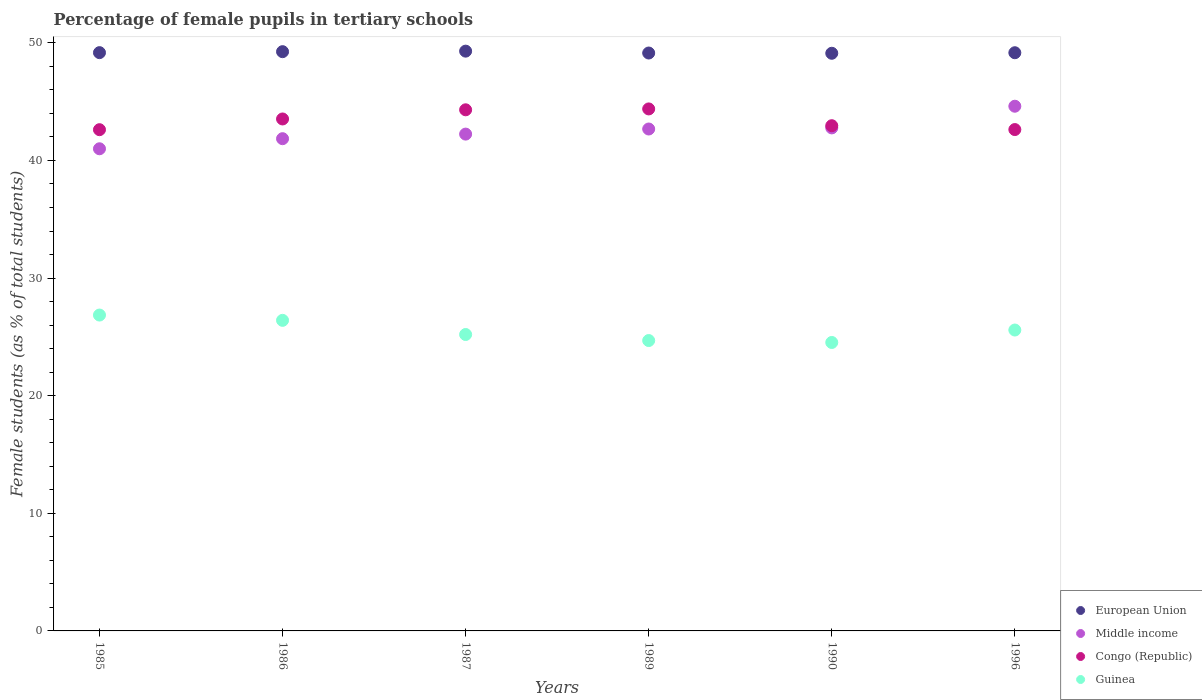What is the percentage of female pupils in tertiary schools in Guinea in 1986?
Provide a succinct answer. 26.41. Across all years, what is the maximum percentage of female pupils in tertiary schools in Middle income?
Your answer should be very brief. 44.61. Across all years, what is the minimum percentage of female pupils in tertiary schools in Guinea?
Give a very brief answer. 24.52. What is the total percentage of female pupils in tertiary schools in European Union in the graph?
Give a very brief answer. 295.12. What is the difference between the percentage of female pupils in tertiary schools in Congo (Republic) in 1985 and that in 1990?
Your answer should be compact. -0.34. What is the difference between the percentage of female pupils in tertiary schools in European Union in 1990 and the percentage of female pupils in tertiary schools in Middle income in 1996?
Offer a very short reply. 4.5. What is the average percentage of female pupils in tertiary schools in Guinea per year?
Ensure brevity in your answer.  25.54. In the year 1996, what is the difference between the percentage of female pupils in tertiary schools in Guinea and percentage of female pupils in tertiary schools in Middle income?
Keep it short and to the point. -19.03. What is the ratio of the percentage of female pupils in tertiary schools in European Union in 1985 to that in 1990?
Provide a succinct answer. 1. What is the difference between the highest and the second highest percentage of female pupils in tertiary schools in Guinea?
Your answer should be compact. 0.45. What is the difference between the highest and the lowest percentage of female pupils in tertiary schools in Congo (Republic)?
Provide a short and direct response. 1.76. In how many years, is the percentage of female pupils in tertiary schools in Congo (Republic) greater than the average percentage of female pupils in tertiary schools in Congo (Republic) taken over all years?
Keep it short and to the point. 3. Is it the case that in every year, the sum of the percentage of female pupils in tertiary schools in Congo (Republic) and percentage of female pupils in tertiary schools in Guinea  is greater than the percentage of female pupils in tertiary schools in European Union?
Your answer should be compact. Yes. Does the percentage of female pupils in tertiary schools in Congo (Republic) monotonically increase over the years?
Your answer should be compact. No. Is the percentage of female pupils in tertiary schools in Middle income strictly less than the percentage of female pupils in tertiary schools in Congo (Republic) over the years?
Your response must be concise. No. How many years are there in the graph?
Ensure brevity in your answer.  6. What is the difference between two consecutive major ticks on the Y-axis?
Your response must be concise. 10. Where does the legend appear in the graph?
Offer a terse response. Bottom right. How many legend labels are there?
Give a very brief answer. 4. How are the legend labels stacked?
Keep it short and to the point. Vertical. What is the title of the graph?
Make the answer very short. Percentage of female pupils in tertiary schools. What is the label or title of the X-axis?
Provide a short and direct response. Years. What is the label or title of the Y-axis?
Give a very brief answer. Female students (as % of total students). What is the Female students (as % of total students) in European Union in 1985?
Your response must be concise. 49.17. What is the Female students (as % of total students) in Middle income in 1985?
Ensure brevity in your answer.  40.99. What is the Female students (as % of total students) in Congo (Republic) in 1985?
Keep it short and to the point. 42.62. What is the Female students (as % of total students) of Guinea in 1985?
Keep it short and to the point. 26.86. What is the Female students (as % of total students) in European Union in 1986?
Offer a terse response. 49.25. What is the Female students (as % of total students) of Middle income in 1986?
Make the answer very short. 41.85. What is the Female students (as % of total students) in Congo (Republic) in 1986?
Keep it short and to the point. 43.53. What is the Female students (as % of total students) of Guinea in 1986?
Your answer should be compact. 26.41. What is the Female students (as % of total students) of European Union in 1987?
Give a very brief answer. 49.3. What is the Female students (as % of total students) in Middle income in 1987?
Offer a very short reply. 42.24. What is the Female students (as % of total students) in Congo (Republic) in 1987?
Your answer should be compact. 44.31. What is the Female students (as % of total students) of Guinea in 1987?
Keep it short and to the point. 25.2. What is the Female students (as % of total students) of European Union in 1989?
Ensure brevity in your answer.  49.14. What is the Female students (as % of total students) in Middle income in 1989?
Make the answer very short. 42.67. What is the Female students (as % of total students) in Congo (Republic) in 1989?
Your response must be concise. 44.38. What is the Female students (as % of total students) of Guinea in 1989?
Offer a very short reply. 24.69. What is the Female students (as % of total students) in European Union in 1990?
Keep it short and to the point. 49.11. What is the Female students (as % of total students) in Middle income in 1990?
Offer a very short reply. 42.77. What is the Female students (as % of total students) in Congo (Republic) in 1990?
Provide a succinct answer. 42.95. What is the Female students (as % of total students) in Guinea in 1990?
Ensure brevity in your answer.  24.52. What is the Female students (as % of total students) of European Union in 1996?
Your response must be concise. 49.16. What is the Female students (as % of total students) of Middle income in 1996?
Keep it short and to the point. 44.61. What is the Female students (as % of total students) of Congo (Republic) in 1996?
Your response must be concise. 42.63. What is the Female students (as % of total students) of Guinea in 1996?
Keep it short and to the point. 25.58. Across all years, what is the maximum Female students (as % of total students) of European Union?
Keep it short and to the point. 49.3. Across all years, what is the maximum Female students (as % of total students) of Middle income?
Your response must be concise. 44.61. Across all years, what is the maximum Female students (as % of total students) of Congo (Republic)?
Provide a succinct answer. 44.38. Across all years, what is the maximum Female students (as % of total students) in Guinea?
Keep it short and to the point. 26.86. Across all years, what is the minimum Female students (as % of total students) of European Union?
Make the answer very short. 49.11. Across all years, what is the minimum Female students (as % of total students) of Middle income?
Offer a terse response. 40.99. Across all years, what is the minimum Female students (as % of total students) in Congo (Republic)?
Keep it short and to the point. 42.62. Across all years, what is the minimum Female students (as % of total students) of Guinea?
Provide a succinct answer. 24.52. What is the total Female students (as % of total students) of European Union in the graph?
Your answer should be very brief. 295.12. What is the total Female students (as % of total students) in Middle income in the graph?
Your answer should be very brief. 255.14. What is the total Female students (as % of total students) of Congo (Republic) in the graph?
Make the answer very short. 260.42. What is the total Female students (as % of total students) of Guinea in the graph?
Your response must be concise. 153.26. What is the difference between the Female students (as % of total students) in European Union in 1985 and that in 1986?
Give a very brief answer. -0.08. What is the difference between the Female students (as % of total students) of Middle income in 1985 and that in 1986?
Give a very brief answer. -0.86. What is the difference between the Female students (as % of total students) in Congo (Republic) in 1985 and that in 1986?
Your answer should be very brief. -0.91. What is the difference between the Female students (as % of total students) in Guinea in 1985 and that in 1986?
Provide a succinct answer. 0.45. What is the difference between the Female students (as % of total students) of European Union in 1985 and that in 1987?
Your answer should be very brief. -0.13. What is the difference between the Female students (as % of total students) in Middle income in 1985 and that in 1987?
Give a very brief answer. -1.25. What is the difference between the Female students (as % of total students) in Congo (Republic) in 1985 and that in 1987?
Provide a short and direct response. -1.69. What is the difference between the Female students (as % of total students) in Guinea in 1985 and that in 1987?
Your answer should be very brief. 1.65. What is the difference between the Female students (as % of total students) of European Union in 1985 and that in 1989?
Your response must be concise. 0.03. What is the difference between the Female students (as % of total students) of Middle income in 1985 and that in 1989?
Give a very brief answer. -1.68. What is the difference between the Female students (as % of total students) in Congo (Republic) in 1985 and that in 1989?
Give a very brief answer. -1.76. What is the difference between the Female students (as % of total students) in Guinea in 1985 and that in 1989?
Offer a terse response. 2.17. What is the difference between the Female students (as % of total students) of European Union in 1985 and that in 1990?
Your response must be concise. 0.05. What is the difference between the Female students (as % of total students) of Middle income in 1985 and that in 1990?
Your response must be concise. -1.77. What is the difference between the Female students (as % of total students) in Congo (Republic) in 1985 and that in 1990?
Your answer should be compact. -0.34. What is the difference between the Female students (as % of total students) in Guinea in 1985 and that in 1990?
Give a very brief answer. 2.33. What is the difference between the Female students (as % of total students) of European Union in 1985 and that in 1996?
Provide a short and direct response. 0.01. What is the difference between the Female students (as % of total students) of Middle income in 1985 and that in 1996?
Your answer should be very brief. -3.62. What is the difference between the Female students (as % of total students) of Congo (Republic) in 1985 and that in 1996?
Keep it short and to the point. -0.01. What is the difference between the Female students (as % of total students) in Guinea in 1985 and that in 1996?
Your response must be concise. 1.27. What is the difference between the Female students (as % of total students) in European Union in 1986 and that in 1987?
Ensure brevity in your answer.  -0.04. What is the difference between the Female students (as % of total students) of Middle income in 1986 and that in 1987?
Keep it short and to the point. -0.39. What is the difference between the Female students (as % of total students) in Congo (Republic) in 1986 and that in 1987?
Provide a short and direct response. -0.78. What is the difference between the Female students (as % of total students) of Guinea in 1986 and that in 1987?
Keep it short and to the point. 1.2. What is the difference between the Female students (as % of total students) in European Union in 1986 and that in 1989?
Keep it short and to the point. 0.11. What is the difference between the Female students (as % of total students) of Middle income in 1986 and that in 1989?
Ensure brevity in your answer.  -0.82. What is the difference between the Female students (as % of total students) in Congo (Republic) in 1986 and that in 1989?
Your answer should be compact. -0.85. What is the difference between the Female students (as % of total students) in Guinea in 1986 and that in 1989?
Your response must be concise. 1.72. What is the difference between the Female students (as % of total students) of European Union in 1986 and that in 1990?
Ensure brevity in your answer.  0.14. What is the difference between the Female students (as % of total students) in Middle income in 1986 and that in 1990?
Ensure brevity in your answer.  -0.92. What is the difference between the Female students (as % of total students) in Congo (Republic) in 1986 and that in 1990?
Make the answer very short. 0.57. What is the difference between the Female students (as % of total students) in Guinea in 1986 and that in 1990?
Your answer should be compact. 1.88. What is the difference between the Female students (as % of total students) of European Union in 1986 and that in 1996?
Provide a succinct answer. 0.09. What is the difference between the Female students (as % of total students) in Middle income in 1986 and that in 1996?
Provide a short and direct response. -2.76. What is the difference between the Female students (as % of total students) of Congo (Republic) in 1986 and that in 1996?
Ensure brevity in your answer.  0.9. What is the difference between the Female students (as % of total students) in Guinea in 1986 and that in 1996?
Provide a succinct answer. 0.82. What is the difference between the Female students (as % of total students) in European Union in 1987 and that in 1989?
Give a very brief answer. 0.16. What is the difference between the Female students (as % of total students) of Middle income in 1987 and that in 1989?
Provide a succinct answer. -0.43. What is the difference between the Female students (as % of total students) in Congo (Republic) in 1987 and that in 1989?
Your answer should be compact. -0.07. What is the difference between the Female students (as % of total students) of Guinea in 1987 and that in 1989?
Give a very brief answer. 0.51. What is the difference between the Female students (as % of total students) in European Union in 1987 and that in 1990?
Provide a short and direct response. 0.18. What is the difference between the Female students (as % of total students) in Middle income in 1987 and that in 1990?
Provide a short and direct response. -0.53. What is the difference between the Female students (as % of total students) of Congo (Republic) in 1987 and that in 1990?
Your answer should be compact. 1.35. What is the difference between the Female students (as % of total students) in Guinea in 1987 and that in 1990?
Give a very brief answer. 0.68. What is the difference between the Female students (as % of total students) of European Union in 1987 and that in 1996?
Your answer should be very brief. 0.14. What is the difference between the Female students (as % of total students) of Middle income in 1987 and that in 1996?
Your response must be concise. -2.37. What is the difference between the Female students (as % of total students) of Congo (Republic) in 1987 and that in 1996?
Your answer should be very brief. 1.68. What is the difference between the Female students (as % of total students) in Guinea in 1987 and that in 1996?
Your answer should be compact. -0.38. What is the difference between the Female students (as % of total students) of European Union in 1989 and that in 1990?
Your answer should be very brief. 0.02. What is the difference between the Female students (as % of total students) of Middle income in 1989 and that in 1990?
Offer a very short reply. -0.09. What is the difference between the Female students (as % of total students) of Congo (Republic) in 1989 and that in 1990?
Offer a very short reply. 1.43. What is the difference between the Female students (as % of total students) in Guinea in 1989 and that in 1990?
Provide a short and direct response. 0.16. What is the difference between the Female students (as % of total students) of European Union in 1989 and that in 1996?
Your response must be concise. -0.02. What is the difference between the Female students (as % of total students) in Middle income in 1989 and that in 1996?
Ensure brevity in your answer.  -1.94. What is the difference between the Female students (as % of total students) of Congo (Republic) in 1989 and that in 1996?
Offer a very short reply. 1.75. What is the difference between the Female students (as % of total students) in Guinea in 1989 and that in 1996?
Offer a terse response. -0.89. What is the difference between the Female students (as % of total students) of European Union in 1990 and that in 1996?
Keep it short and to the point. -0.05. What is the difference between the Female students (as % of total students) in Middle income in 1990 and that in 1996?
Provide a succinct answer. -1.84. What is the difference between the Female students (as % of total students) in Congo (Republic) in 1990 and that in 1996?
Your answer should be compact. 0.33. What is the difference between the Female students (as % of total students) in Guinea in 1990 and that in 1996?
Make the answer very short. -1.06. What is the difference between the Female students (as % of total students) of European Union in 1985 and the Female students (as % of total students) of Middle income in 1986?
Keep it short and to the point. 7.32. What is the difference between the Female students (as % of total students) in European Union in 1985 and the Female students (as % of total students) in Congo (Republic) in 1986?
Your answer should be very brief. 5.64. What is the difference between the Female students (as % of total students) of European Union in 1985 and the Female students (as % of total students) of Guinea in 1986?
Provide a succinct answer. 22.76. What is the difference between the Female students (as % of total students) of Middle income in 1985 and the Female students (as % of total students) of Congo (Republic) in 1986?
Your response must be concise. -2.53. What is the difference between the Female students (as % of total students) of Middle income in 1985 and the Female students (as % of total students) of Guinea in 1986?
Your answer should be compact. 14.59. What is the difference between the Female students (as % of total students) in Congo (Republic) in 1985 and the Female students (as % of total students) in Guinea in 1986?
Ensure brevity in your answer.  16.21. What is the difference between the Female students (as % of total students) of European Union in 1985 and the Female students (as % of total students) of Middle income in 1987?
Offer a very short reply. 6.93. What is the difference between the Female students (as % of total students) of European Union in 1985 and the Female students (as % of total students) of Congo (Republic) in 1987?
Provide a short and direct response. 4.86. What is the difference between the Female students (as % of total students) of European Union in 1985 and the Female students (as % of total students) of Guinea in 1987?
Your answer should be very brief. 23.97. What is the difference between the Female students (as % of total students) of Middle income in 1985 and the Female students (as % of total students) of Congo (Republic) in 1987?
Provide a succinct answer. -3.31. What is the difference between the Female students (as % of total students) in Middle income in 1985 and the Female students (as % of total students) in Guinea in 1987?
Provide a succinct answer. 15.79. What is the difference between the Female students (as % of total students) of Congo (Republic) in 1985 and the Female students (as % of total students) of Guinea in 1987?
Offer a terse response. 17.41. What is the difference between the Female students (as % of total students) in European Union in 1985 and the Female students (as % of total students) in Middle income in 1989?
Your answer should be very brief. 6.49. What is the difference between the Female students (as % of total students) of European Union in 1985 and the Female students (as % of total students) of Congo (Republic) in 1989?
Ensure brevity in your answer.  4.79. What is the difference between the Female students (as % of total students) of European Union in 1985 and the Female students (as % of total students) of Guinea in 1989?
Your answer should be very brief. 24.48. What is the difference between the Female students (as % of total students) in Middle income in 1985 and the Female students (as % of total students) in Congo (Republic) in 1989?
Offer a terse response. -3.39. What is the difference between the Female students (as % of total students) of Middle income in 1985 and the Female students (as % of total students) of Guinea in 1989?
Provide a short and direct response. 16.31. What is the difference between the Female students (as % of total students) in Congo (Republic) in 1985 and the Female students (as % of total students) in Guinea in 1989?
Provide a short and direct response. 17.93. What is the difference between the Female students (as % of total students) of European Union in 1985 and the Female students (as % of total students) of Middle income in 1990?
Keep it short and to the point. 6.4. What is the difference between the Female students (as % of total students) in European Union in 1985 and the Female students (as % of total students) in Congo (Republic) in 1990?
Give a very brief answer. 6.21. What is the difference between the Female students (as % of total students) of European Union in 1985 and the Female students (as % of total students) of Guinea in 1990?
Offer a terse response. 24.64. What is the difference between the Female students (as % of total students) of Middle income in 1985 and the Female students (as % of total students) of Congo (Republic) in 1990?
Ensure brevity in your answer.  -1.96. What is the difference between the Female students (as % of total students) of Middle income in 1985 and the Female students (as % of total students) of Guinea in 1990?
Offer a very short reply. 16.47. What is the difference between the Female students (as % of total students) in Congo (Republic) in 1985 and the Female students (as % of total students) in Guinea in 1990?
Keep it short and to the point. 18.09. What is the difference between the Female students (as % of total students) in European Union in 1985 and the Female students (as % of total students) in Middle income in 1996?
Give a very brief answer. 4.56. What is the difference between the Female students (as % of total students) of European Union in 1985 and the Female students (as % of total students) of Congo (Republic) in 1996?
Offer a terse response. 6.54. What is the difference between the Female students (as % of total students) in European Union in 1985 and the Female students (as % of total students) in Guinea in 1996?
Your answer should be compact. 23.58. What is the difference between the Female students (as % of total students) of Middle income in 1985 and the Female students (as % of total students) of Congo (Republic) in 1996?
Offer a very short reply. -1.63. What is the difference between the Female students (as % of total students) in Middle income in 1985 and the Female students (as % of total students) in Guinea in 1996?
Ensure brevity in your answer.  15.41. What is the difference between the Female students (as % of total students) in Congo (Republic) in 1985 and the Female students (as % of total students) in Guinea in 1996?
Make the answer very short. 17.03. What is the difference between the Female students (as % of total students) of European Union in 1986 and the Female students (as % of total students) of Middle income in 1987?
Provide a short and direct response. 7.01. What is the difference between the Female students (as % of total students) of European Union in 1986 and the Female students (as % of total students) of Congo (Republic) in 1987?
Provide a succinct answer. 4.94. What is the difference between the Female students (as % of total students) in European Union in 1986 and the Female students (as % of total students) in Guinea in 1987?
Your answer should be compact. 24.05. What is the difference between the Female students (as % of total students) of Middle income in 1986 and the Female students (as % of total students) of Congo (Republic) in 1987?
Keep it short and to the point. -2.46. What is the difference between the Female students (as % of total students) in Middle income in 1986 and the Female students (as % of total students) in Guinea in 1987?
Give a very brief answer. 16.65. What is the difference between the Female students (as % of total students) in Congo (Republic) in 1986 and the Female students (as % of total students) in Guinea in 1987?
Give a very brief answer. 18.33. What is the difference between the Female students (as % of total students) in European Union in 1986 and the Female students (as % of total students) in Middle income in 1989?
Ensure brevity in your answer.  6.58. What is the difference between the Female students (as % of total students) in European Union in 1986 and the Female students (as % of total students) in Congo (Republic) in 1989?
Give a very brief answer. 4.87. What is the difference between the Female students (as % of total students) of European Union in 1986 and the Female students (as % of total students) of Guinea in 1989?
Provide a succinct answer. 24.56. What is the difference between the Female students (as % of total students) in Middle income in 1986 and the Female students (as % of total students) in Congo (Republic) in 1989?
Your response must be concise. -2.53. What is the difference between the Female students (as % of total students) of Middle income in 1986 and the Female students (as % of total students) of Guinea in 1989?
Give a very brief answer. 17.16. What is the difference between the Female students (as % of total students) in Congo (Republic) in 1986 and the Female students (as % of total students) in Guinea in 1989?
Ensure brevity in your answer.  18.84. What is the difference between the Female students (as % of total students) of European Union in 1986 and the Female students (as % of total students) of Middle income in 1990?
Offer a terse response. 6.48. What is the difference between the Female students (as % of total students) of European Union in 1986 and the Female students (as % of total students) of Congo (Republic) in 1990?
Offer a very short reply. 6.3. What is the difference between the Female students (as % of total students) in European Union in 1986 and the Female students (as % of total students) in Guinea in 1990?
Keep it short and to the point. 24.73. What is the difference between the Female students (as % of total students) of Middle income in 1986 and the Female students (as % of total students) of Congo (Republic) in 1990?
Offer a very short reply. -1.1. What is the difference between the Female students (as % of total students) in Middle income in 1986 and the Female students (as % of total students) in Guinea in 1990?
Offer a very short reply. 17.33. What is the difference between the Female students (as % of total students) in Congo (Republic) in 1986 and the Female students (as % of total students) in Guinea in 1990?
Give a very brief answer. 19. What is the difference between the Female students (as % of total students) in European Union in 1986 and the Female students (as % of total students) in Middle income in 1996?
Your response must be concise. 4.64. What is the difference between the Female students (as % of total students) of European Union in 1986 and the Female students (as % of total students) of Congo (Republic) in 1996?
Provide a short and direct response. 6.62. What is the difference between the Female students (as % of total students) in European Union in 1986 and the Female students (as % of total students) in Guinea in 1996?
Your answer should be compact. 23.67. What is the difference between the Female students (as % of total students) in Middle income in 1986 and the Female students (as % of total students) in Congo (Republic) in 1996?
Ensure brevity in your answer.  -0.78. What is the difference between the Female students (as % of total students) of Middle income in 1986 and the Female students (as % of total students) of Guinea in 1996?
Your answer should be compact. 16.27. What is the difference between the Female students (as % of total students) of Congo (Republic) in 1986 and the Female students (as % of total students) of Guinea in 1996?
Provide a succinct answer. 17.95. What is the difference between the Female students (as % of total students) in European Union in 1987 and the Female students (as % of total students) in Middle income in 1989?
Give a very brief answer. 6.62. What is the difference between the Female students (as % of total students) of European Union in 1987 and the Female students (as % of total students) of Congo (Republic) in 1989?
Keep it short and to the point. 4.91. What is the difference between the Female students (as % of total students) in European Union in 1987 and the Female students (as % of total students) in Guinea in 1989?
Offer a terse response. 24.61. What is the difference between the Female students (as % of total students) of Middle income in 1987 and the Female students (as % of total students) of Congo (Republic) in 1989?
Your answer should be compact. -2.14. What is the difference between the Female students (as % of total students) in Middle income in 1987 and the Female students (as % of total students) in Guinea in 1989?
Your response must be concise. 17.55. What is the difference between the Female students (as % of total students) of Congo (Republic) in 1987 and the Female students (as % of total students) of Guinea in 1989?
Keep it short and to the point. 19.62. What is the difference between the Female students (as % of total students) of European Union in 1987 and the Female students (as % of total students) of Middle income in 1990?
Your answer should be compact. 6.53. What is the difference between the Female students (as % of total students) in European Union in 1987 and the Female students (as % of total students) in Congo (Republic) in 1990?
Your answer should be very brief. 6.34. What is the difference between the Female students (as % of total students) of European Union in 1987 and the Female students (as % of total students) of Guinea in 1990?
Give a very brief answer. 24.77. What is the difference between the Female students (as % of total students) of Middle income in 1987 and the Female students (as % of total students) of Congo (Republic) in 1990?
Make the answer very short. -0.71. What is the difference between the Female students (as % of total students) of Middle income in 1987 and the Female students (as % of total students) of Guinea in 1990?
Provide a short and direct response. 17.72. What is the difference between the Female students (as % of total students) of Congo (Republic) in 1987 and the Female students (as % of total students) of Guinea in 1990?
Keep it short and to the point. 19.78. What is the difference between the Female students (as % of total students) of European Union in 1987 and the Female students (as % of total students) of Middle income in 1996?
Your answer should be compact. 4.68. What is the difference between the Female students (as % of total students) of European Union in 1987 and the Female students (as % of total students) of Congo (Republic) in 1996?
Offer a terse response. 6.67. What is the difference between the Female students (as % of total students) of European Union in 1987 and the Female students (as % of total students) of Guinea in 1996?
Ensure brevity in your answer.  23.71. What is the difference between the Female students (as % of total students) in Middle income in 1987 and the Female students (as % of total students) in Congo (Republic) in 1996?
Ensure brevity in your answer.  -0.39. What is the difference between the Female students (as % of total students) of Middle income in 1987 and the Female students (as % of total students) of Guinea in 1996?
Offer a very short reply. 16.66. What is the difference between the Female students (as % of total students) of Congo (Republic) in 1987 and the Female students (as % of total students) of Guinea in 1996?
Provide a short and direct response. 18.72. What is the difference between the Female students (as % of total students) in European Union in 1989 and the Female students (as % of total students) in Middle income in 1990?
Provide a succinct answer. 6.37. What is the difference between the Female students (as % of total students) in European Union in 1989 and the Female students (as % of total students) in Congo (Republic) in 1990?
Provide a short and direct response. 6.18. What is the difference between the Female students (as % of total students) in European Union in 1989 and the Female students (as % of total students) in Guinea in 1990?
Keep it short and to the point. 24.61. What is the difference between the Female students (as % of total students) of Middle income in 1989 and the Female students (as % of total students) of Congo (Republic) in 1990?
Provide a short and direct response. -0.28. What is the difference between the Female students (as % of total students) of Middle income in 1989 and the Female students (as % of total students) of Guinea in 1990?
Provide a short and direct response. 18.15. What is the difference between the Female students (as % of total students) of Congo (Republic) in 1989 and the Female students (as % of total students) of Guinea in 1990?
Keep it short and to the point. 19.86. What is the difference between the Female students (as % of total students) in European Union in 1989 and the Female students (as % of total students) in Middle income in 1996?
Provide a succinct answer. 4.52. What is the difference between the Female students (as % of total students) of European Union in 1989 and the Female students (as % of total students) of Congo (Republic) in 1996?
Offer a very short reply. 6.51. What is the difference between the Female students (as % of total students) in European Union in 1989 and the Female students (as % of total students) in Guinea in 1996?
Your answer should be very brief. 23.55. What is the difference between the Female students (as % of total students) of Middle income in 1989 and the Female students (as % of total students) of Congo (Republic) in 1996?
Ensure brevity in your answer.  0.05. What is the difference between the Female students (as % of total students) in Middle income in 1989 and the Female students (as % of total students) in Guinea in 1996?
Your answer should be very brief. 17.09. What is the difference between the Female students (as % of total students) in Congo (Republic) in 1989 and the Female students (as % of total students) in Guinea in 1996?
Offer a very short reply. 18.8. What is the difference between the Female students (as % of total students) of European Union in 1990 and the Female students (as % of total students) of Middle income in 1996?
Give a very brief answer. 4.5. What is the difference between the Female students (as % of total students) of European Union in 1990 and the Female students (as % of total students) of Congo (Republic) in 1996?
Offer a very short reply. 6.49. What is the difference between the Female students (as % of total students) of European Union in 1990 and the Female students (as % of total students) of Guinea in 1996?
Ensure brevity in your answer.  23.53. What is the difference between the Female students (as % of total students) in Middle income in 1990 and the Female students (as % of total students) in Congo (Republic) in 1996?
Keep it short and to the point. 0.14. What is the difference between the Female students (as % of total students) of Middle income in 1990 and the Female students (as % of total students) of Guinea in 1996?
Give a very brief answer. 17.19. What is the difference between the Female students (as % of total students) of Congo (Republic) in 1990 and the Female students (as % of total students) of Guinea in 1996?
Give a very brief answer. 17.37. What is the average Female students (as % of total students) in European Union per year?
Offer a terse response. 49.19. What is the average Female students (as % of total students) of Middle income per year?
Make the answer very short. 42.52. What is the average Female students (as % of total students) of Congo (Republic) per year?
Keep it short and to the point. 43.4. What is the average Female students (as % of total students) of Guinea per year?
Offer a very short reply. 25.54. In the year 1985, what is the difference between the Female students (as % of total students) of European Union and Female students (as % of total students) of Middle income?
Your answer should be compact. 8.17. In the year 1985, what is the difference between the Female students (as % of total students) in European Union and Female students (as % of total students) in Congo (Republic)?
Offer a very short reply. 6.55. In the year 1985, what is the difference between the Female students (as % of total students) in European Union and Female students (as % of total students) in Guinea?
Offer a very short reply. 22.31. In the year 1985, what is the difference between the Female students (as % of total students) in Middle income and Female students (as % of total students) in Congo (Republic)?
Provide a short and direct response. -1.62. In the year 1985, what is the difference between the Female students (as % of total students) in Middle income and Female students (as % of total students) in Guinea?
Provide a succinct answer. 14.14. In the year 1985, what is the difference between the Female students (as % of total students) in Congo (Republic) and Female students (as % of total students) in Guinea?
Keep it short and to the point. 15.76. In the year 1986, what is the difference between the Female students (as % of total students) in European Union and Female students (as % of total students) in Middle income?
Your answer should be very brief. 7.4. In the year 1986, what is the difference between the Female students (as % of total students) of European Union and Female students (as % of total students) of Congo (Republic)?
Your response must be concise. 5.72. In the year 1986, what is the difference between the Female students (as % of total students) of European Union and Female students (as % of total students) of Guinea?
Offer a terse response. 22.84. In the year 1986, what is the difference between the Female students (as % of total students) of Middle income and Female students (as % of total students) of Congo (Republic)?
Make the answer very short. -1.68. In the year 1986, what is the difference between the Female students (as % of total students) of Middle income and Female students (as % of total students) of Guinea?
Provide a short and direct response. 15.45. In the year 1986, what is the difference between the Female students (as % of total students) of Congo (Republic) and Female students (as % of total students) of Guinea?
Offer a terse response. 17.12. In the year 1987, what is the difference between the Female students (as % of total students) in European Union and Female students (as % of total students) in Middle income?
Keep it short and to the point. 7.05. In the year 1987, what is the difference between the Female students (as % of total students) in European Union and Female students (as % of total students) in Congo (Republic)?
Your answer should be compact. 4.99. In the year 1987, what is the difference between the Female students (as % of total students) of European Union and Female students (as % of total students) of Guinea?
Give a very brief answer. 24.09. In the year 1987, what is the difference between the Female students (as % of total students) of Middle income and Female students (as % of total students) of Congo (Republic)?
Your response must be concise. -2.07. In the year 1987, what is the difference between the Female students (as % of total students) in Middle income and Female students (as % of total students) in Guinea?
Your answer should be compact. 17.04. In the year 1987, what is the difference between the Female students (as % of total students) in Congo (Republic) and Female students (as % of total students) in Guinea?
Your answer should be very brief. 19.11. In the year 1989, what is the difference between the Female students (as % of total students) in European Union and Female students (as % of total students) in Middle income?
Provide a short and direct response. 6.46. In the year 1989, what is the difference between the Female students (as % of total students) of European Union and Female students (as % of total students) of Congo (Republic)?
Offer a terse response. 4.75. In the year 1989, what is the difference between the Female students (as % of total students) in European Union and Female students (as % of total students) in Guinea?
Give a very brief answer. 24.45. In the year 1989, what is the difference between the Female students (as % of total students) of Middle income and Female students (as % of total students) of Congo (Republic)?
Your answer should be compact. -1.71. In the year 1989, what is the difference between the Female students (as % of total students) in Middle income and Female students (as % of total students) in Guinea?
Make the answer very short. 17.99. In the year 1989, what is the difference between the Female students (as % of total students) in Congo (Republic) and Female students (as % of total students) in Guinea?
Keep it short and to the point. 19.69. In the year 1990, what is the difference between the Female students (as % of total students) in European Union and Female students (as % of total students) in Middle income?
Provide a short and direct response. 6.35. In the year 1990, what is the difference between the Female students (as % of total students) in European Union and Female students (as % of total students) in Congo (Republic)?
Your response must be concise. 6.16. In the year 1990, what is the difference between the Female students (as % of total students) of European Union and Female students (as % of total students) of Guinea?
Your response must be concise. 24.59. In the year 1990, what is the difference between the Female students (as % of total students) of Middle income and Female students (as % of total students) of Congo (Republic)?
Provide a succinct answer. -0.19. In the year 1990, what is the difference between the Female students (as % of total students) of Middle income and Female students (as % of total students) of Guinea?
Offer a terse response. 18.24. In the year 1990, what is the difference between the Female students (as % of total students) in Congo (Republic) and Female students (as % of total students) in Guinea?
Your answer should be compact. 18.43. In the year 1996, what is the difference between the Female students (as % of total students) of European Union and Female students (as % of total students) of Middle income?
Ensure brevity in your answer.  4.55. In the year 1996, what is the difference between the Female students (as % of total students) of European Union and Female students (as % of total students) of Congo (Republic)?
Provide a short and direct response. 6.53. In the year 1996, what is the difference between the Female students (as % of total students) of European Union and Female students (as % of total students) of Guinea?
Give a very brief answer. 23.58. In the year 1996, what is the difference between the Female students (as % of total students) in Middle income and Female students (as % of total students) in Congo (Republic)?
Make the answer very short. 1.98. In the year 1996, what is the difference between the Female students (as % of total students) in Middle income and Female students (as % of total students) in Guinea?
Keep it short and to the point. 19.03. In the year 1996, what is the difference between the Female students (as % of total students) of Congo (Republic) and Female students (as % of total students) of Guinea?
Your answer should be very brief. 17.04. What is the ratio of the Female students (as % of total students) of Middle income in 1985 to that in 1986?
Give a very brief answer. 0.98. What is the ratio of the Female students (as % of total students) in Congo (Republic) in 1985 to that in 1986?
Your answer should be compact. 0.98. What is the ratio of the Female students (as % of total students) of Middle income in 1985 to that in 1987?
Provide a short and direct response. 0.97. What is the ratio of the Female students (as % of total students) in Congo (Republic) in 1985 to that in 1987?
Offer a very short reply. 0.96. What is the ratio of the Female students (as % of total students) of Guinea in 1985 to that in 1987?
Ensure brevity in your answer.  1.07. What is the ratio of the Female students (as % of total students) in European Union in 1985 to that in 1989?
Offer a very short reply. 1. What is the ratio of the Female students (as % of total students) in Middle income in 1985 to that in 1989?
Offer a very short reply. 0.96. What is the ratio of the Female students (as % of total students) in Congo (Republic) in 1985 to that in 1989?
Offer a very short reply. 0.96. What is the ratio of the Female students (as % of total students) of Guinea in 1985 to that in 1989?
Provide a succinct answer. 1.09. What is the ratio of the Female students (as % of total students) in Middle income in 1985 to that in 1990?
Provide a succinct answer. 0.96. What is the ratio of the Female students (as % of total students) of Congo (Republic) in 1985 to that in 1990?
Give a very brief answer. 0.99. What is the ratio of the Female students (as % of total students) of Guinea in 1985 to that in 1990?
Your answer should be very brief. 1.1. What is the ratio of the Female students (as % of total students) in European Union in 1985 to that in 1996?
Make the answer very short. 1. What is the ratio of the Female students (as % of total students) in Middle income in 1985 to that in 1996?
Make the answer very short. 0.92. What is the ratio of the Female students (as % of total students) of Congo (Republic) in 1985 to that in 1996?
Your answer should be compact. 1. What is the ratio of the Female students (as % of total students) in Guinea in 1985 to that in 1996?
Give a very brief answer. 1.05. What is the ratio of the Female students (as % of total students) in Middle income in 1986 to that in 1987?
Provide a short and direct response. 0.99. What is the ratio of the Female students (as % of total students) of Congo (Republic) in 1986 to that in 1987?
Provide a succinct answer. 0.98. What is the ratio of the Female students (as % of total students) of Guinea in 1986 to that in 1987?
Ensure brevity in your answer.  1.05. What is the ratio of the Female students (as % of total students) of European Union in 1986 to that in 1989?
Your answer should be very brief. 1. What is the ratio of the Female students (as % of total students) in Middle income in 1986 to that in 1989?
Keep it short and to the point. 0.98. What is the ratio of the Female students (as % of total students) of Congo (Republic) in 1986 to that in 1989?
Offer a very short reply. 0.98. What is the ratio of the Female students (as % of total students) in Guinea in 1986 to that in 1989?
Keep it short and to the point. 1.07. What is the ratio of the Female students (as % of total students) of Middle income in 1986 to that in 1990?
Ensure brevity in your answer.  0.98. What is the ratio of the Female students (as % of total students) of Congo (Republic) in 1986 to that in 1990?
Provide a short and direct response. 1.01. What is the ratio of the Female students (as % of total students) of Guinea in 1986 to that in 1990?
Make the answer very short. 1.08. What is the ratio of the Female students (as % of total students) of Middle income in 1986 to that in 1996?
Your answer should be very brief. 0.94. What is the ratio of the Female students (as % of total students) of Congo (Republic) in 1986 to that in 1996?
Make the answer very short. 1.02. What is the ratio of the Female students (as % of total students) in Guinea in 1986 to that in 1996?
Give a very brief answer. 1.03. What is the ratio of the Female students (as % of total students) in European Union in 1987 to that in 1989?
Offer a terse response. 1. What is the ratio of the Female students (as % of total students) of Middle income in 1987 to that in 1989?
Offer a very short reply. 0.99. What is the ratio of the Female students (as % of total students) in Congo (Republic) in 1987 to that in 1989?
Offer a terse response. 1. What is the ratio of the Female students (as % of total students) in Guinea in 1987 to that in 1989?
Ensure brevity in your answer.  1.02. What is the ratio of the Female students (as % of total students) of European Union in 1987 to that in 1990?
Provide a succinct answer. 1. What is the ratio of the Female students (as % of total students) in Middle income in 1987 to that in 1990?
Offer a terse response. 0.99. What is the ratio of the Female students (as % of total students) of Congo (Republic) in 1987 to that in 1990?
Offer a terse response. 1.03. What is the ratio of the Female students (as % of total students) in Guinea in 1987 to that in 1990?
Make the answer very short. 1.03. What is the ratio of the Female students (as % of total students) in European Union in 1987 to that in 1996?
Provide a short and direct response. 1. What is the ratio of the Female students (as % of total students) of Middle income in 1987 to that in 1996?
Your answer should be compact. 0.95. What is the ratio of the Female students (as % of total students) of Congo (Republic) in 1987 to that in 1996?
Ensure brevity in your answer.  1.04. What is the ratio of the Female students (as % of total students) in Guinea in 1987 to that in 1996?
Offer a very short reply. 0.99. What is the ratio of the Female students (as % of total students) in European Union in 1989 to that in 1990?
Keep it short and to the point. 1. What is the ratio of the Female students (as % of total students) of Congo (Republic) in 1989 to that in 1990?
Your answer should be very brief. 1.03. What is the ratio of the Female students (as % of total students) in Guinea in 1989 to that in 1990?
Give a very brief answer. 1.01. What is the ratio of the Female students (as % of total students) in Middle income in 1989 to that in 1996?
Ensure brevity in your answer.  0.96. What is the ratio of the Female students (as % of total students) in Congo (Republic) in 1989 to that in 1996?
Make the answer very short. 1.04. What is the ratio of the Female students (as % of total students) in Guinea in 1989 to that in 1996?
Give a very brief answer. 0.96. What is the ratio of the Female students (as % of total students) of Middle income in 1990 to that in 1996?
Keep it short and to the point. 0.96. What is the ratio of the Female students (as % of total students) of Congo (Republic) in 1990 to that in 1996?
Offer a very short reply. 1.01. What is the ratio of the Female students (as % of total students) of Guinea in 1990 to that in 1996?
Provide a short and direct response. 0.96. What is the difference between the highest and the second highest Female students (as % of total students) in European Union?
Give a very brief answer. 0.04. What is the difference between the highest and the second highest Female students (as % of total students) of Middle income?
Keep it short and to the point. 1.84. What is the difference between the highest and the second highest Female students (as % of total students) of Congo (Republic)?
Give a very brief answer. 0.07. What is the difference between the highest and the second highest Female students (as % of total students) of Guinea?
Keep it short and to the point. 0.45. What is the difference between the highest and the lowest Female students (as % of total students) of European Union?
Keep it short and to the point. 0.18. What is the difference between the highest and the lowest Female students (as % of total students) of Middle income?
Offer a very short reply. 3.62. What is the difference between the highest and the lowest Female students (as % of total students) of Congo (Republic)?
Your answer should be very brief. 1.76. What is the difference between the highest and the lowest Female students (as % of total students) of Guinea?
Your response must be concise. 2.33. 